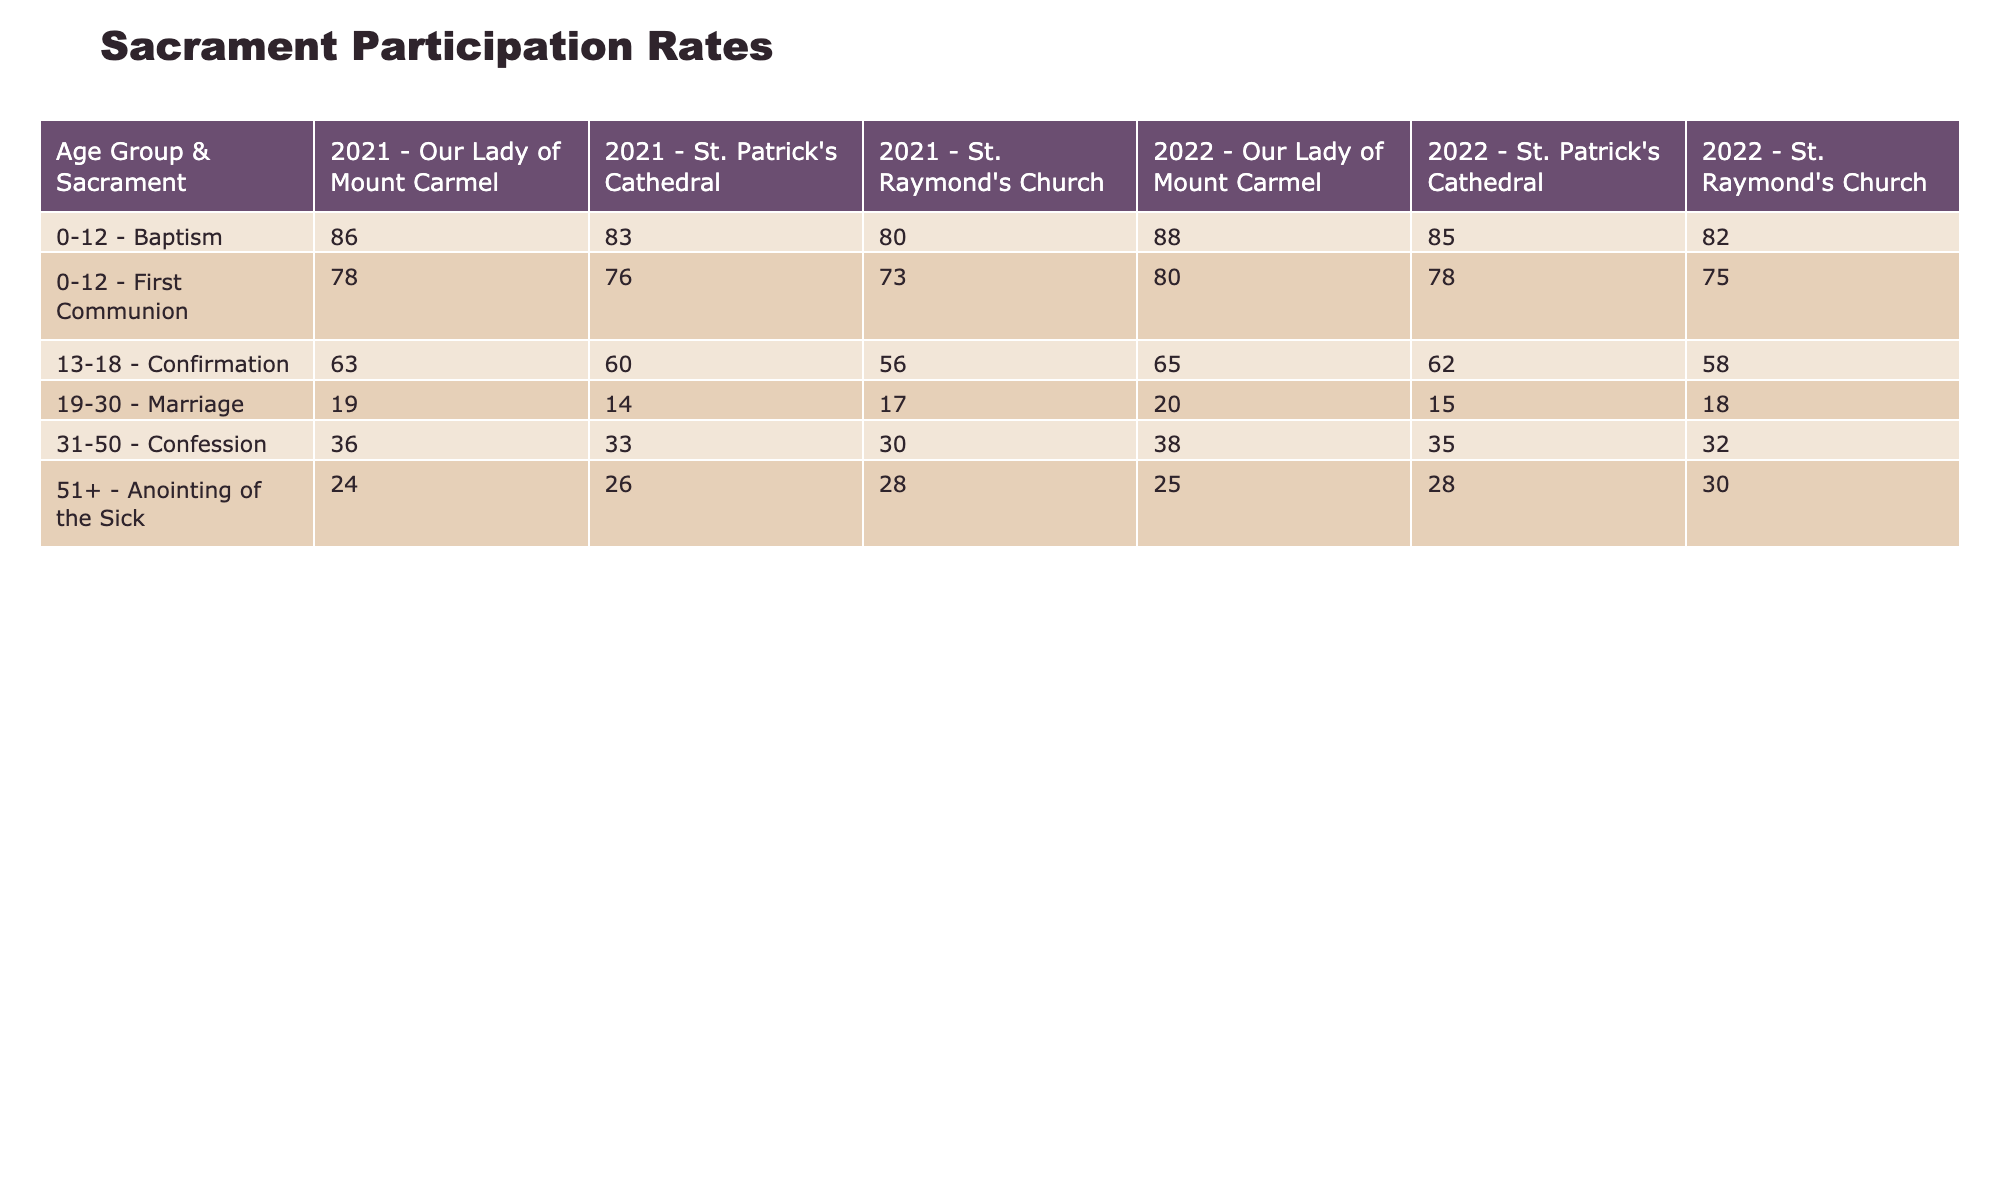What is the participation rate for Baptism in the 0-12 age group at St. Patrick's Cathedral in 2022? Referring to the table, under the Age Group 0-12 and the Sacrament Baptism for the Parish St. Patrick's Cathedral in the year 2022, the participation rate is listed as 85.
Answer: 85 What is the average participation rate for Confirmation in the 13-18 age group across all parishes for 2021? Looking at the Confirmation participation rates for the age group 13-18, the values are 60 (St. Patrick's Cathedral), 56 (St. Raymond's Church), and 63 (Our Lady of Mount Carmel). Adding these gives 60 + 56 + 63 = 179, and dividing by 3 gives an average of 179/3 = 59.67.
Answer: 59.67 Is the participation rate for Anointing of the Sick higher in the 51+ age group at St. Raymond's Church or Our Lady of Mount Carmel for 2022? Checking the table, for Anointing of the Sick in the 51+ age group, St. Raymond's Church has a participation rate of 30, while Our Lady of Mount Carmel has a participation rate of 25. Since 30 is greater than 25, the answer is St. Raymond's Church has a higher rate.
Answer: Yes How much higher is the participation rate for First Communion in the 0-12 age group at Our Lady of Mount Carmel compared to St. Patrick's Cathedral in 2022? For First Communion in the 0-12 age group, the participation rate at Our Lady of Mount Carmel is 80, while at St. Patrick's Cathedral, it is 78. The difference is calculated as 80 - 78 = 2, indicating that Our Lady of Mount Carmel has a participation rate that is 2 percentage points higher.
Answer: 2 Which sacrament has the lowest participation rate in the 19-30 age group across all parishes in 2022? Reviewing the table, for the 19-30 age group, Marriage participation rates are 15 (St. Patrick's Cathedral), 18 (St. Raymond's Church), and 20 (Our Lady of Mount Carmel). The lowest among these is 15, which belongs to St. Patrick's Cathedral.
Answer: 15 What is the total participation rate for Confession in the 31-50 age group across all parishes for 2022? The Confession participation rates for the 31-50 age group are 35 (St. Patrick's Cathedral), 32 (St. Raymond's Church), and 38 (Our Lady of Mount Carmel). Adding these together gives 35 + 32 + 38 = 105, which represents the total participation rate for Confession in this age group.
Answer: 105 Was the participation rate for Baptism in the 0-12 age group at Our Lady of Mount Carmel in 2021 lower than the rate at St. Patrick's Cathedral in the same year? From the table, Baptism participation rates for the 0-12 age group in 2021 show Our Lady of Mount Carmel at 86 and St. Patrick's Cathedral at 83. Since 86 is greater than 83, the rate at Our Lady of Mount Carmel was higher.
Answer: No In which year did the participation rate for Marriage in the 19-30 age group peak at St. Raymond's Church? Looking at the table, the Marriage participation rates for St. Raymond's Church in the 19-30 age group are 18 in 2022 and 17 in 2021. The higher participation rate of 18 in 2022 indicates that it was the peak year.
Answer: 2022 